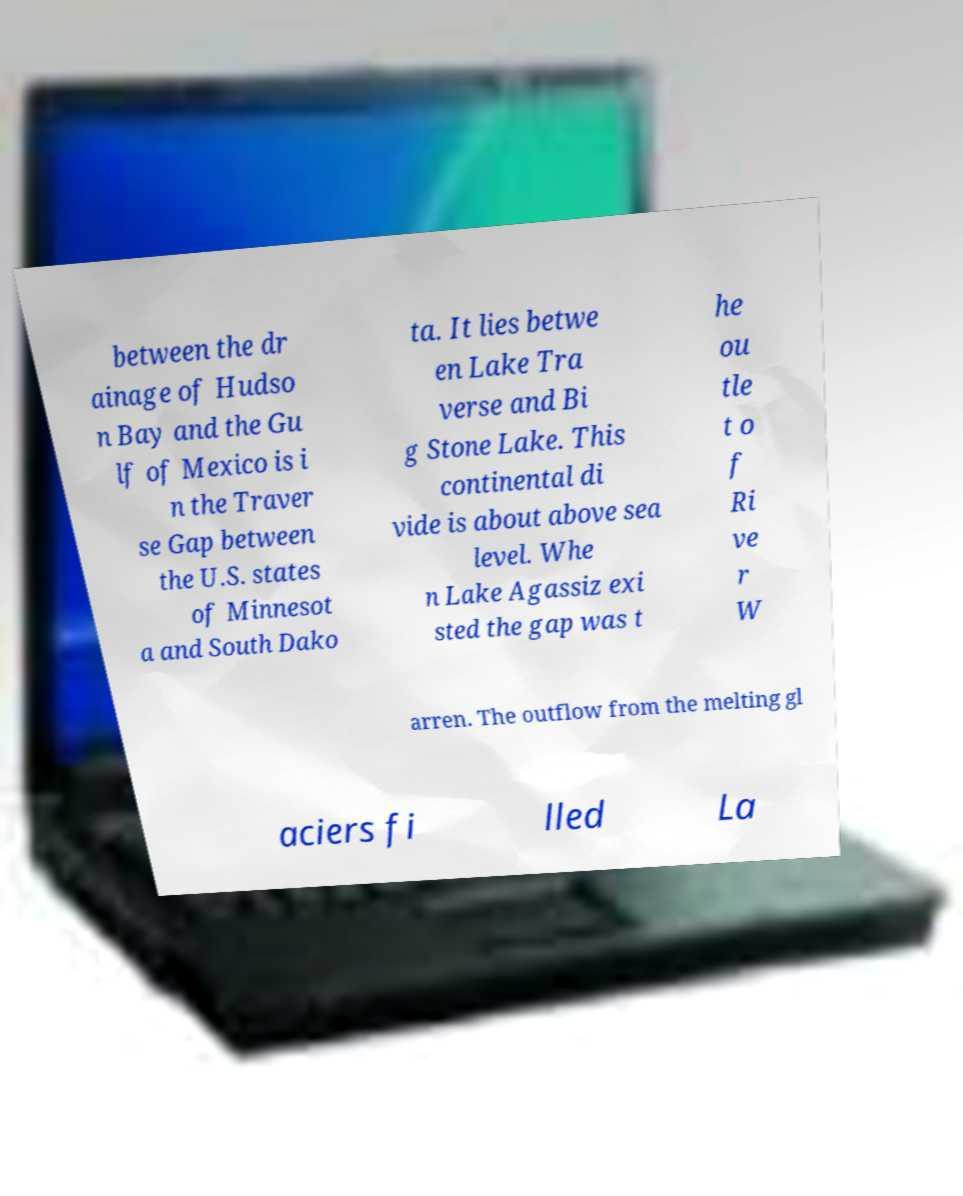Could you assist in decoding the text presented in this image and type it out clearly? between the dr ainage of Hudso n Bay and the Gu lf of Mexico is i n the Traver se Gap between the U.S. states of Minnesot a and South Dako ta. It lies betwe en Lake Tra verse and Bi g Stone Lake. This continental di vide is about above sea level. Whe n Lake Agassiz exi sted the gap was t he ou tle t o f Ri ve r W arren. The outflow from the melting gl aciers fi lled La 